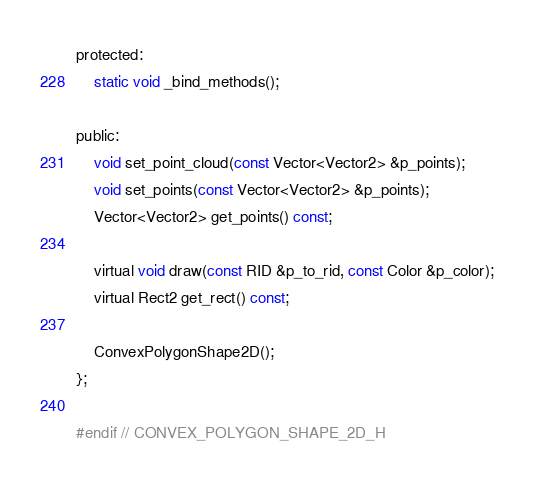<code> <loc_0><loc_0><loc_500><loc_500><_C_>protected:
	static void _bind_methods();

public:
	void set_point_cloud(const Vector<Vector2> &p_points);
	void set_points(const Vector<Vector2> &p_points);
	Vector<Vector2> get_points() const;

	virtual void draw(const RID &p_to_rid, const Color &p_color);
	virtual Rect2 get_rect() const;

	ConvexPolygonShape2D();
};

#endif // CONVEX_POLYGON_SHAPE_2D_H
</code> 